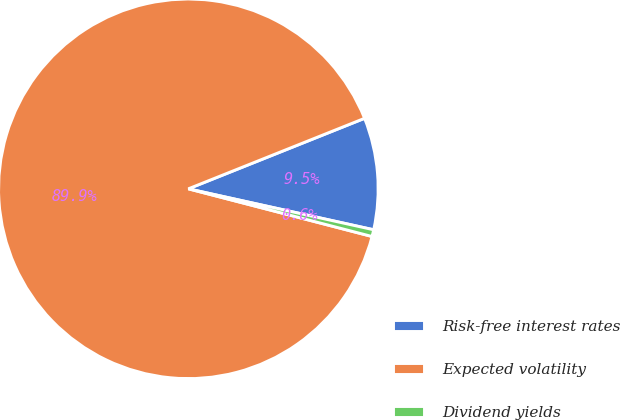Convert chart to OTSL. <chart><loc_0><loc_0><loc_500><loc_500><pie_chart><fcel>Risk-free interest rates<fcel>Expected volatility<fcel>Dividend yields<nl><fcel>9.52%<fcel>89.9%<fcel>0.58%<nl></chart> 